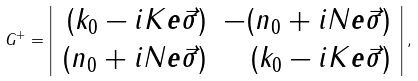<formula> <loc_0><loc_0><loc_500><loc_500>G ^ { + } = \left | \begin{array} { r r } ( k _ { 0 } - i K { \boldsymbol e } \vec { \sigma } ) & - ( n _ { 0 } + i N { \boldsymbol e } \vec { \sigma } ) \\ ( n _ { 0 } + i N { \boldsymbol e } \vec { \sigma } ) & ( k _ { 0 } - i K { \boldsymbol e } \vec { \sigma } ) \end{array} \right | ,</formula> 